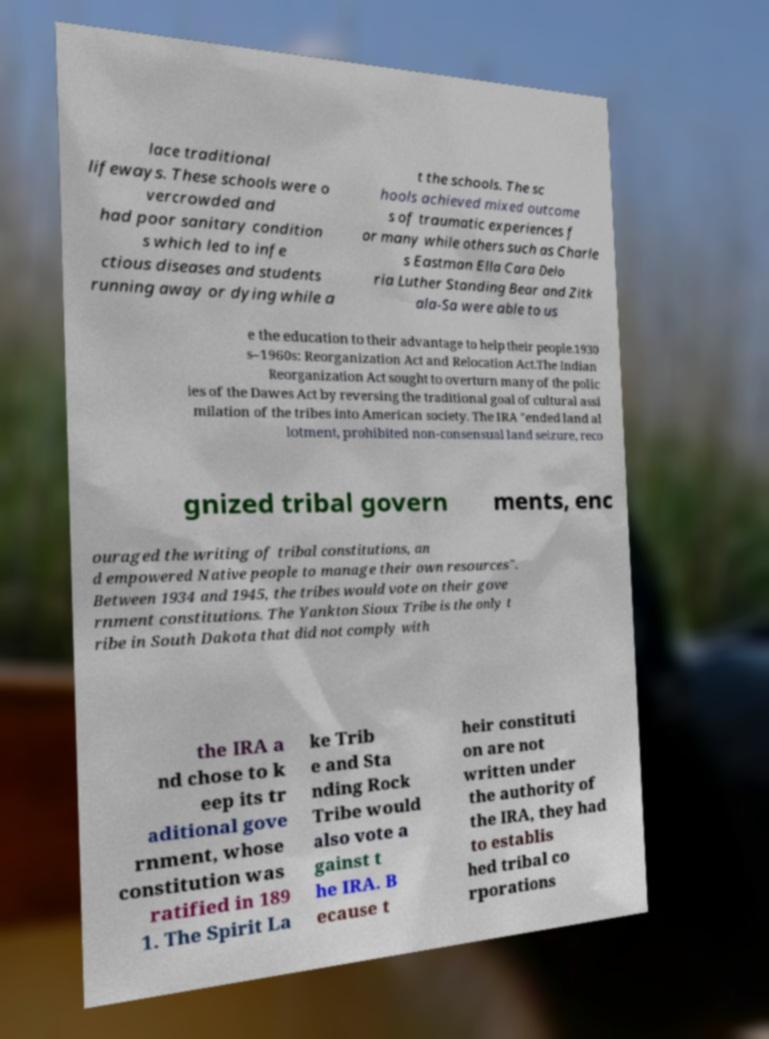What messages or text are displayed in this image? I need them in a readable, typed format. lace traditional lifeways. These schools were o vercrowded and had poor sanitary condition s which led to infe ctious diseases and students running away or dying while a t the schools. The sc hools achieved mixed outcome s of traumatic experiences f or many while others such as Charle s Eastman Ella Cara Delo ria Luther Standing Bear and Zitk ala-Sa were able to us e the education to their advantage to help their people.1930 s–1960s: Reorganization Act and Relocation Act.The Indian Reorganization Act sought to overturn many of the polic ies of the Dawes Act by reversing the traditional goal of cultural assi milation of the tribes into American society. The IRA "ended land al lotment, prohibited non-consensual land seizure, reco gnized tribal govern ments, enc ouraged the writing of tribal constitutions, an d empowered Native people to manage their own resources". Between 1934 and 1945, the tribes would vote on their gove rnment constitutions. The Yankton Sioux Tribe is the only t ribe in South Dakota that did not comply with the IRA a nd chose to k eep its tr aditional gove rnment, whose constitution was ratified in 189 1. The Spirit La ke Trib e and Sta nding Rock Tribe would also vote a gainst t he IRA. B ecause t heir constituti on are not written under the authority of the IRA, they had to establis hed tribal co rporations 